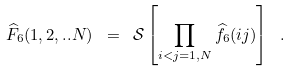<formula> <loc_0><loc_0><loc_500><loc_500>\widehat { F } _ { 6 } ( 1 , 2 , . . N ) \ = \ \mathcal { S } \left [ \prod _ { i < j = 1 , N } \widehat { f } _ { 6 } ( i j ) \right ] \ .</formula> 